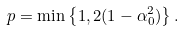Convert formula to latex. <formula><loc_0><loc_0><loc_500><loc_500>p = \min \left \{ 1 , 2 ( 1 - \alpha _ { 0 } ^ { 2 } ) \right \} .</formula> 